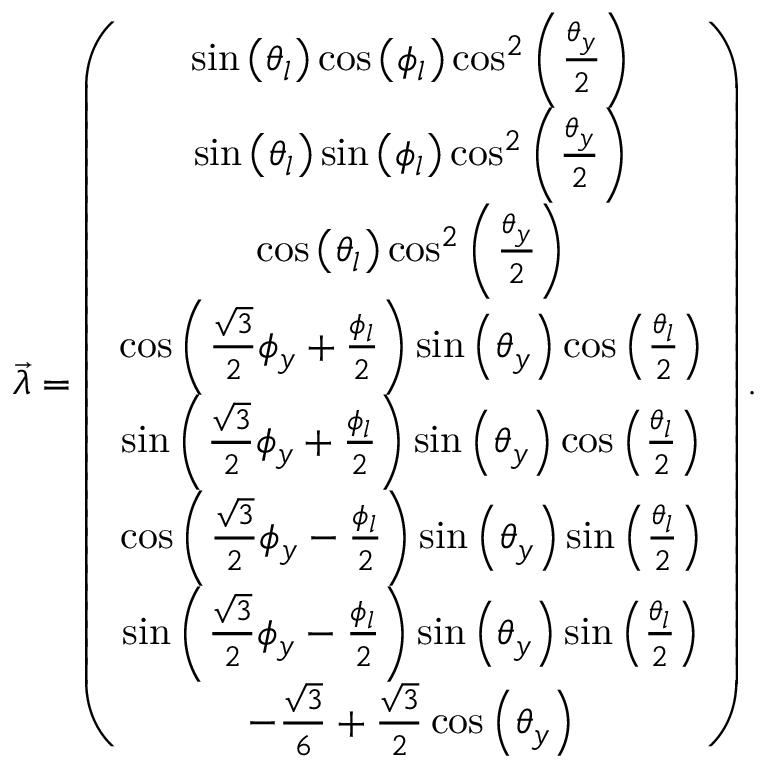Convert formula to latex. <formula><loc_0><loc_0><loc_500><loc_500>\begin{array} { r } { \overrightarrow { \lambda } = \left ( \begin{array} { c } { \sin \left ( \theta _ { l } \right ) \cos \left ( \phi _ { l } \right ) \cos ^ { 2 } \left ( \frac { \theta _ { y } } { 2 } \right ) } \\ { \sin \left ( \theta _ { l } \right ) \sin \left ( \phi _ { l } \right ) \cos ^ { 2 } \left ( \frac { \theta _ { y } } { 2 } \right ) } \\ { \cos \left ( \theta _ { l } \right ) \cos ^ { 2 } \left ( \frac { \theta _ { y } } { 2 } \right ) } \\ { \cos \left ( \frac { \sqrt { 3 } } { 2 } \phi _ { y } + \frac { \phi _ { l } } { 2 } \right ) \sin \left ( \theta _ { y } \right ) \cos \left ( \frac { \theta _ { l } } { 2 } \right ) } \\ { \sin \left ( \frac { \sqrt { 3 } } { 2 } \phi _ { y } + \frac { \phi _ { l } } { 2 } \right ) \sin \left ( \theta _ { y } \right ) \cos \left ( \frac { \theta _ { l } } { 2 } \right ) } \\ { \cos \left ( \frac { \sqrt { 3 } } { 2 } \phi _ { y } - \frac { \phi _ { l } } { 2 } \right ) \sin \left ( \theta _ { y } \right ) \sin \left ( \frac { \theta _ { l } } { 2 } \right ) } \\ { \sin \left ( \frac { \sqrt { 3 } } { 2 } \phi _ { y } - \frac { \phi _ { l } } { 2 } \right ) \sin \left ( \theta _ { y } \right ) \sin \left ( \frac { \theta _ { l } } { 2 } \right ) } \\ { - \frac { \sqrt { 3 } } { 6 } + \frac { \sqrt { 3 } } { 2 } \cos \left ( \theta _ { y } \right ) } \end{array} \right ) . } \end{array}</formula> 